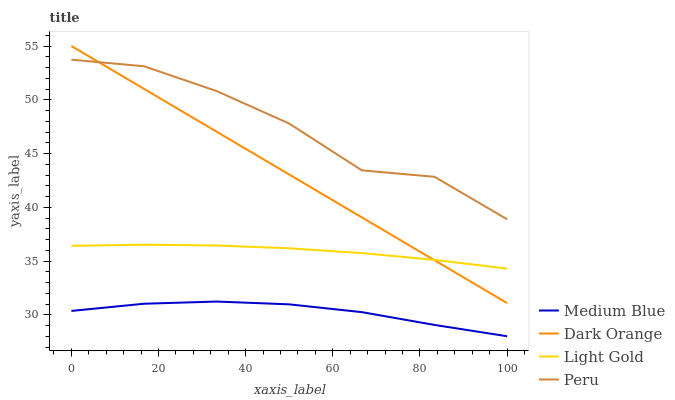Does Medium Blue have the minimum area under the curve?
Answer yes or no. Yes. Does Peru have the maximum area under the curve?
Answer yes or no. Yes. Does Light Gold have the minimum area under the curve?
Answer yes or no. No. Does Light Gold have the maximum area under the curve?
Answer yes or no. No. Is Dark Orange the smoothest?
Answer yes or no. Yes. Is Peru the roughest?
Answer yes or no. Yes. Is Light Gold the smoothest?
Answer yes or no. No. Is Light Gold the roughest?
Answer yes or no. No. Does Medium Blue have the lowest value?
Answer yes or no. Yes. Does Light Gold have the lowest value?
Answer yes or no. No. Does Dark Orange have the highest value?
Answer yes or no. Yes. Does Light Gold have the highest value?
Answer yes or no. No. Is Light Gold less than Peru?
Answer yes or no. Yes. Is Peru greater than Light Gold?
Answer yes or no. Yes. Does Dark Orange intersect Light Gold?
Answer yes or no. Yes. Is Dark Orange less than Light Gold?
Answer yes or no. No. Is Dark Orange greater than Light Gold?
Answer yes or no. No. Does Light Gold intersect Peru?
Answer yes or no. No. 